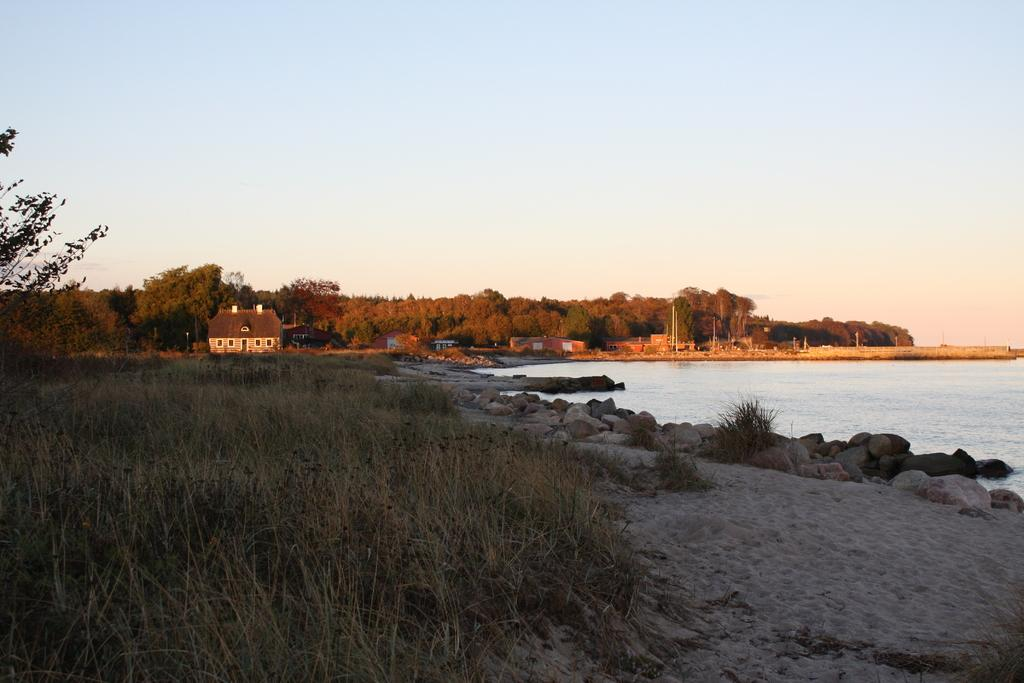What type of landscape is depicted in the image? There is a grassland in the image. What can be seen in the distance behind the grassland? There are trees in the background of the image. What structures are located on the right side of the image? There are houses on the right side of the image. What body of water is present on the right side of the image? There is a lake on the right side of the image. What part of the natural environment is visible in the image? The sky is visible in the image. What type of brass instrument can be heard playing songs in the image? There is no brass instrument or music playing in the image; it is a still image of a grassland, trees, houses, a lake, and the sky. 